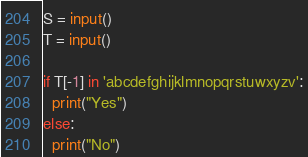<code> <loc_0><loc_0><loc_500><loc_500><_Python_>S = input()
T = input()

if T[-1] in 'abcdefghijklmnopqrstuwxyzv':
  print("Yes")
else:
  print("No")</code> 